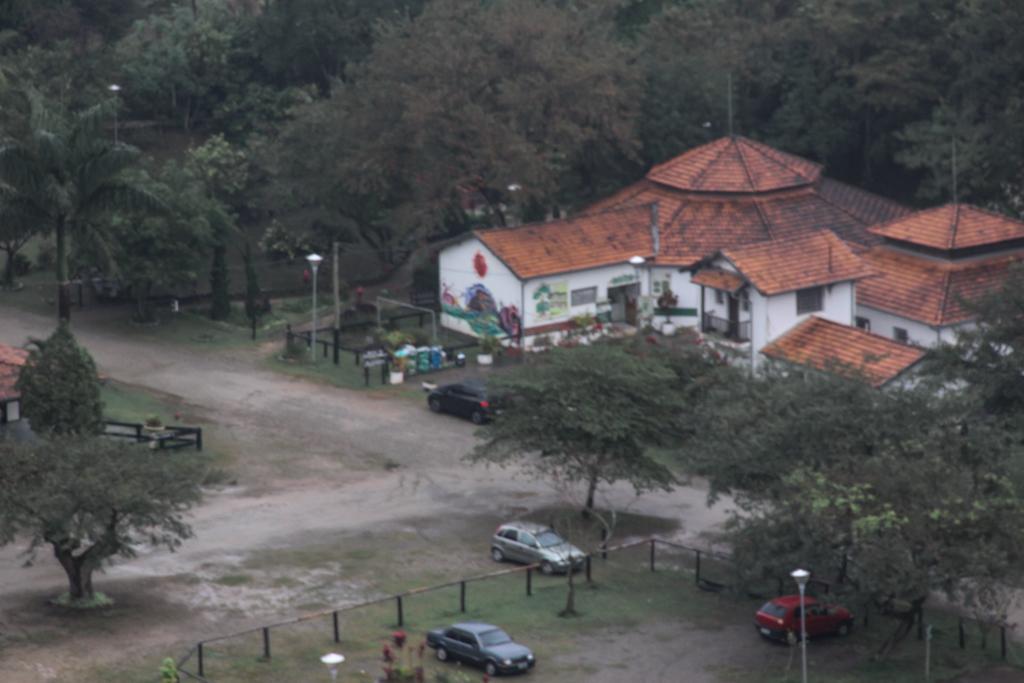How would you summarize this image in a sentence or two? In the picture we can see a road which is in the shape of a T and on the three sides we can see grass surfaces and trees and on one side we can see a house building with some cars parked near it and railing. 